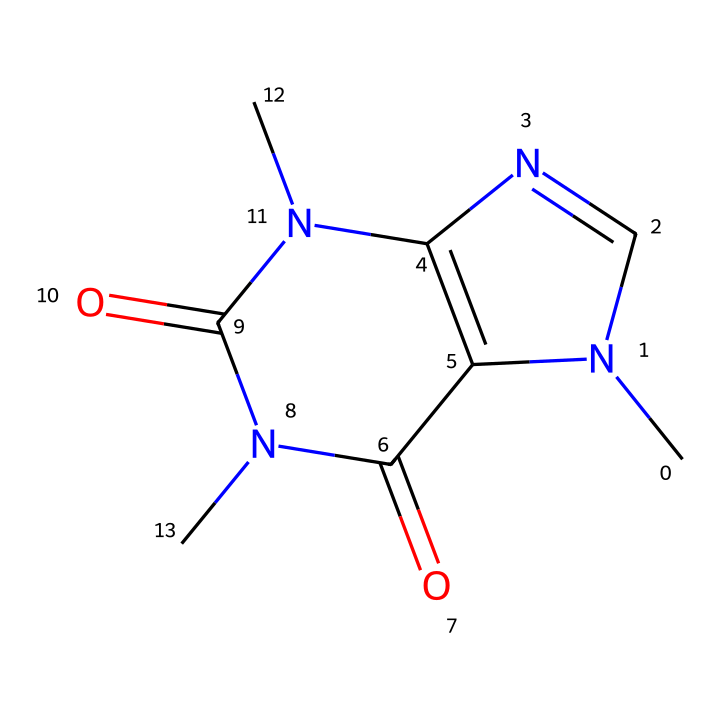What is the molecular formula of caffeine? To determine the molecular formula, we can analyze the structure represented by the SMILES notation. The chemical consists of Carbon (C), Nitrogen (N), and Oxygen (O) atoms. Counting each atom, we find that there are 8 carbon atoms, 10 hydrogen atoms, 4 nitrogen atoms, and 2 oxygen atoms. Combining these gives us the molecular formula: C8H10N4O2.
Answer: C8H10N4O2 How many rings are present in the caffeine structure? By examining the SMILES structure, we can identify the cyclic nature of the molecule. The two "N" and the interconnected "C" atoms form a ring structure, which we can visually trace. There are two distinct rings present in caffeine.
Answer: 2 What is the most common property of caffeine as a non-electrolyte? Non-electrolytes do not dissociate into ions in solution. Based on the structure of caffeine, it is primarily a large organic molecule with covalent bonds, which means it retains its molecular integrity in liquid form without forming ions. Thus, its most common property is that it does not conduct electricity in solution.
Answer: does not conduct electricity Which element in caffeine’s structure contributes to its basicity? In the structure of caffeine, nitrogen atoms are present. The lone pairs on nitrogen allow it to accept protons, which contributes to the basicity of caffeine. This characteristic can be traced back to the nitrogen's ability to engage in protonation reactions, making it a basic compound.
Answer: nitrogen How many polar functional groups are present in caffeine? To analyze the SMILES, we note the functional groups displayed in the structure. Caffeine features amide groups connected to its carbon backbone, which introduces polarity. The amide groups are polar due to the presence of carbonyl (C=O) bonds. By counting the functional groups, we see that there are two polar functional groups within the caffeine structure.
Answer: 2 